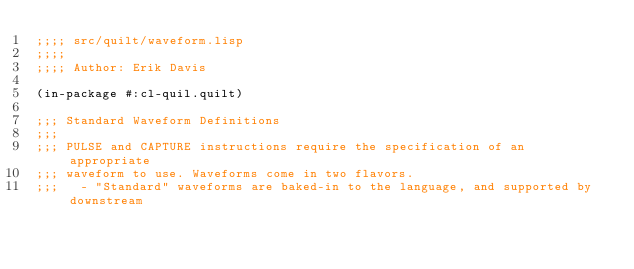<code> <loc_0><loc_0><loc_500><loc_500><_Lisp_>;;;; src/quilt/waveform.lisp
;;;;
;;;; Author: Erik Davis

(in-package #:cl-quil.quilt)

;;; Standard Waveform Definitions
;;;
;;; PULSE and CAPTURE instructions require the specification of an appropriate
;;; waveform to use. Waveforms come in two flavors.
;;;   - "Standard" waveforms are baked-in to the language, and supported by downstream</code> 